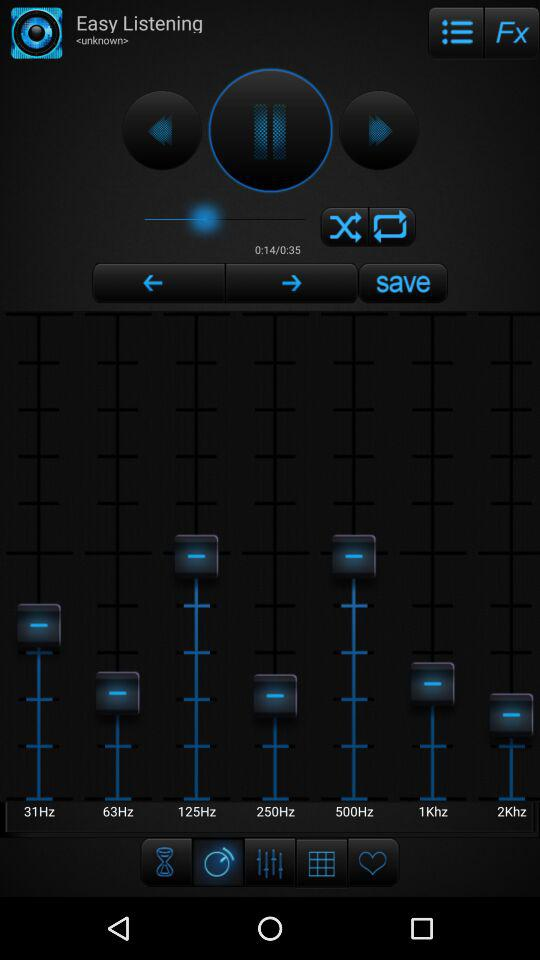What is the total duration of the playing audio? The total duration is 35 seconds. 